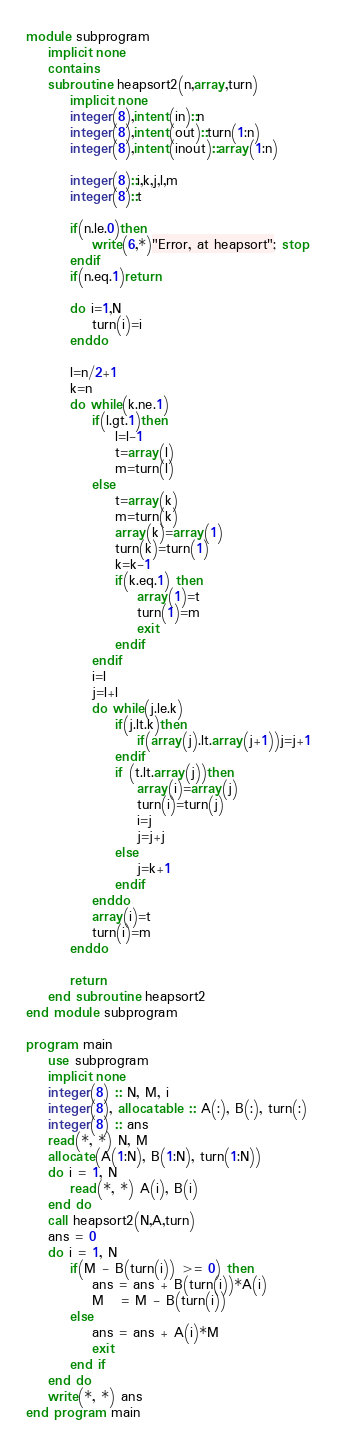Convert code to text. <code><loc_0><loc_0><loc_500><loc_500><_FORTRAN_>module subprogram
	implicit none
	contains
	subroutine heapsort2(n,array,turn)
		implicit none
		integer(8),intent(in)::n
		integer(8),intent(out)::turn(1:n)
		integer(8),intent(inout)::array(1:n)
  
		integer(8)::i,k,j,l,m
		integer(8)::t
  
		if(n.le.0)then
			write(6,*)"Error, at heapsort"; stop
		endif
		if(n.eq.1)return
 
		do i=1,N
			turn(i)=i
		enddo
 
		l=n/2+1
		k=n
		do while(k.ne.1)
			if(l.gt.1)then
				l=l-1
				t=array(l)
				m=turn(l)
			else
				t=array(k)
				m=turn(k)
				array(k)=array(1)
				turn(k)=turn(1)
				k=k-1
				if(k.eq.1) then
					array(1)=t
					turn(1)=m
					exit
				endif
			endif
			i=l
			j=l+l
			do while(j.le.k)
				if(j.lt.k)then
					if(array(j).lt.array(j+1))j=j+1
				endif
				if (t.lt.array(j))then
					array(i)=array(j)
					turn(i)=turn(j)
					i=j
					j=j+j
				else
					j=k+1
				endif
			enddo
			array(i)=t
			turn(i)=m
		enddo
 
		return
	end subroutine heapsort2
end module subprogram	

program main
	use subprogram
	implicit none
	integer(8) :: N, M, i
	integer(8), allocatable :: A(:), B(:), turn(:)
	integer(8) :: ans
	read(*, *) N, M
	allocate(A(1:N), B(1:N), turn(1:N))
	do i = 1, N
		read(*, *) A(i), B(i)
	end do
	call heapsort2(N,A,turn)
	ans = 0
	do i = 1, N
		if(M - B(turn(i)) >= 0) then
			ans = ans + B(turn(i))*A(i)
			M   = M - B(turn(i))
		else
			ans = ans + A(i)*M
			exit
		end if
	end do
	write(*, *) ans
end program main</code> 